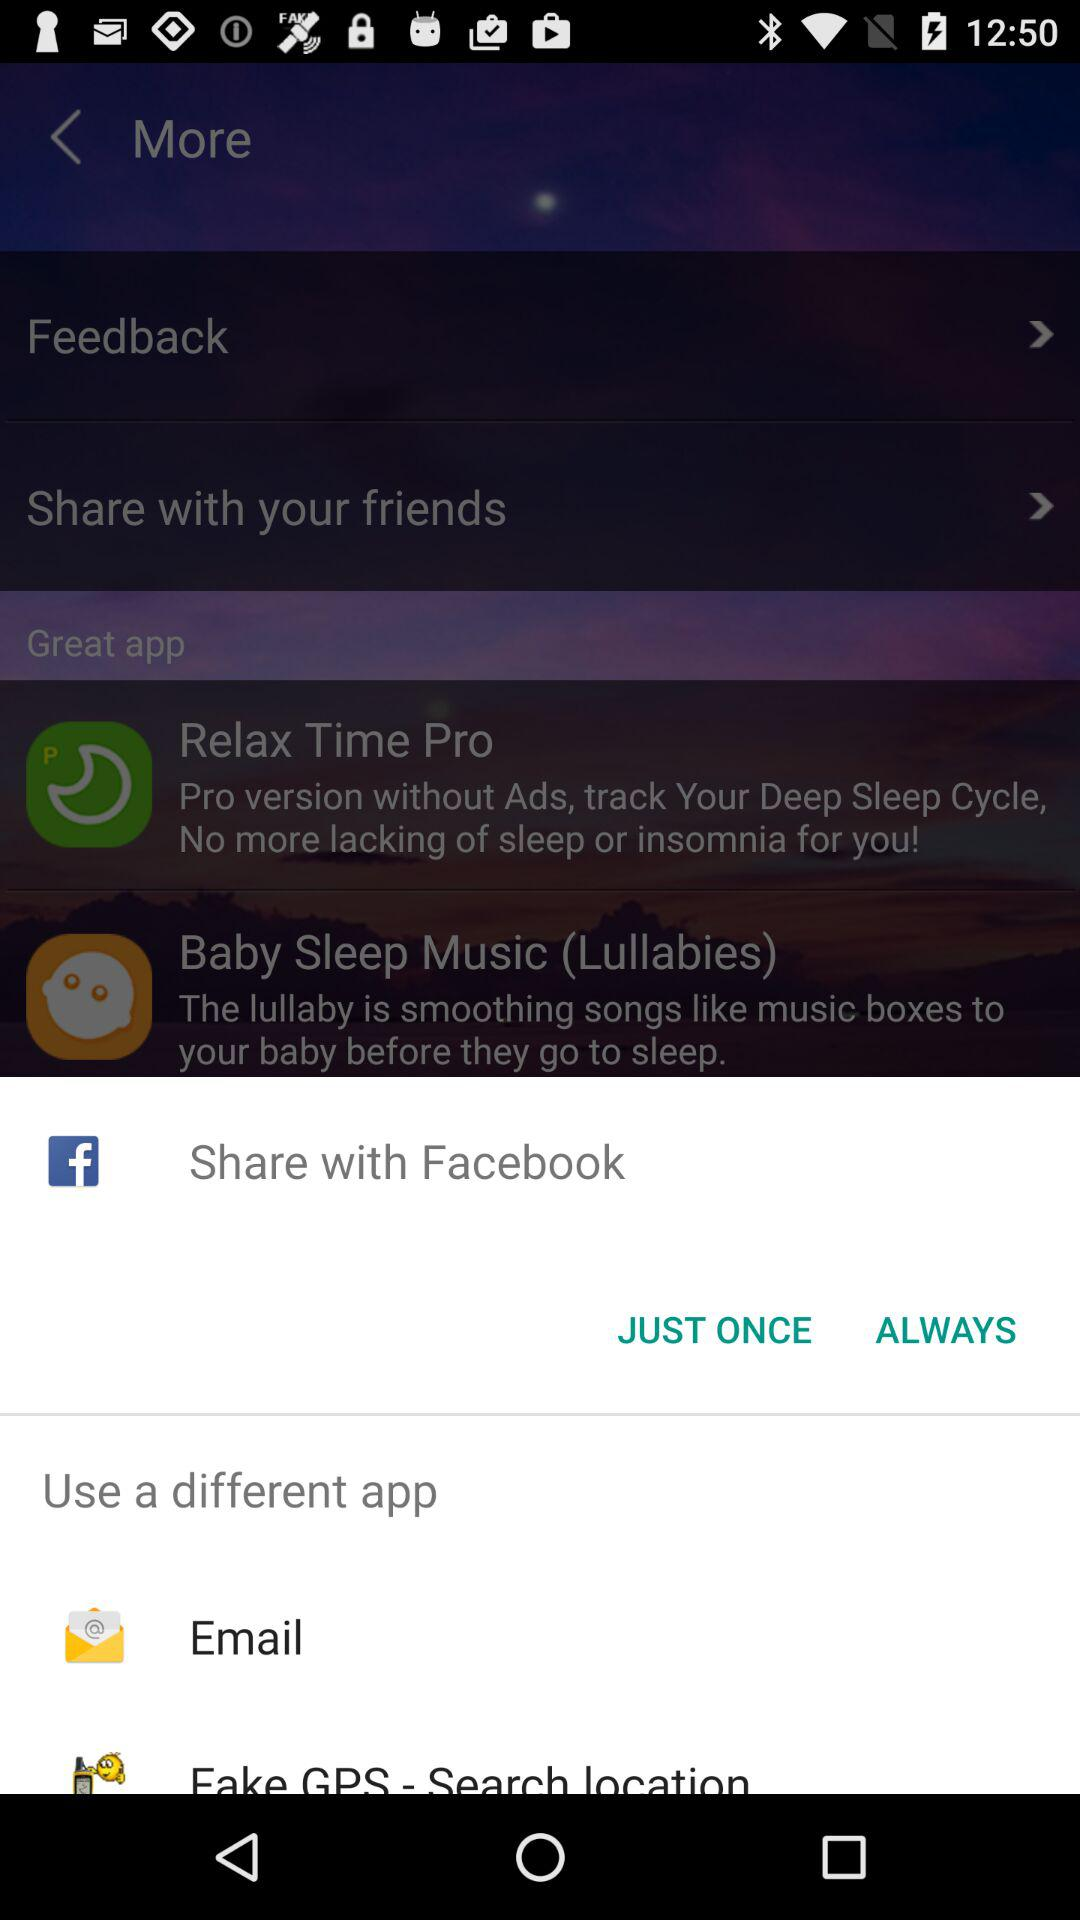Which sharing options are given? The sharing options are "Facebook" and "Email". 